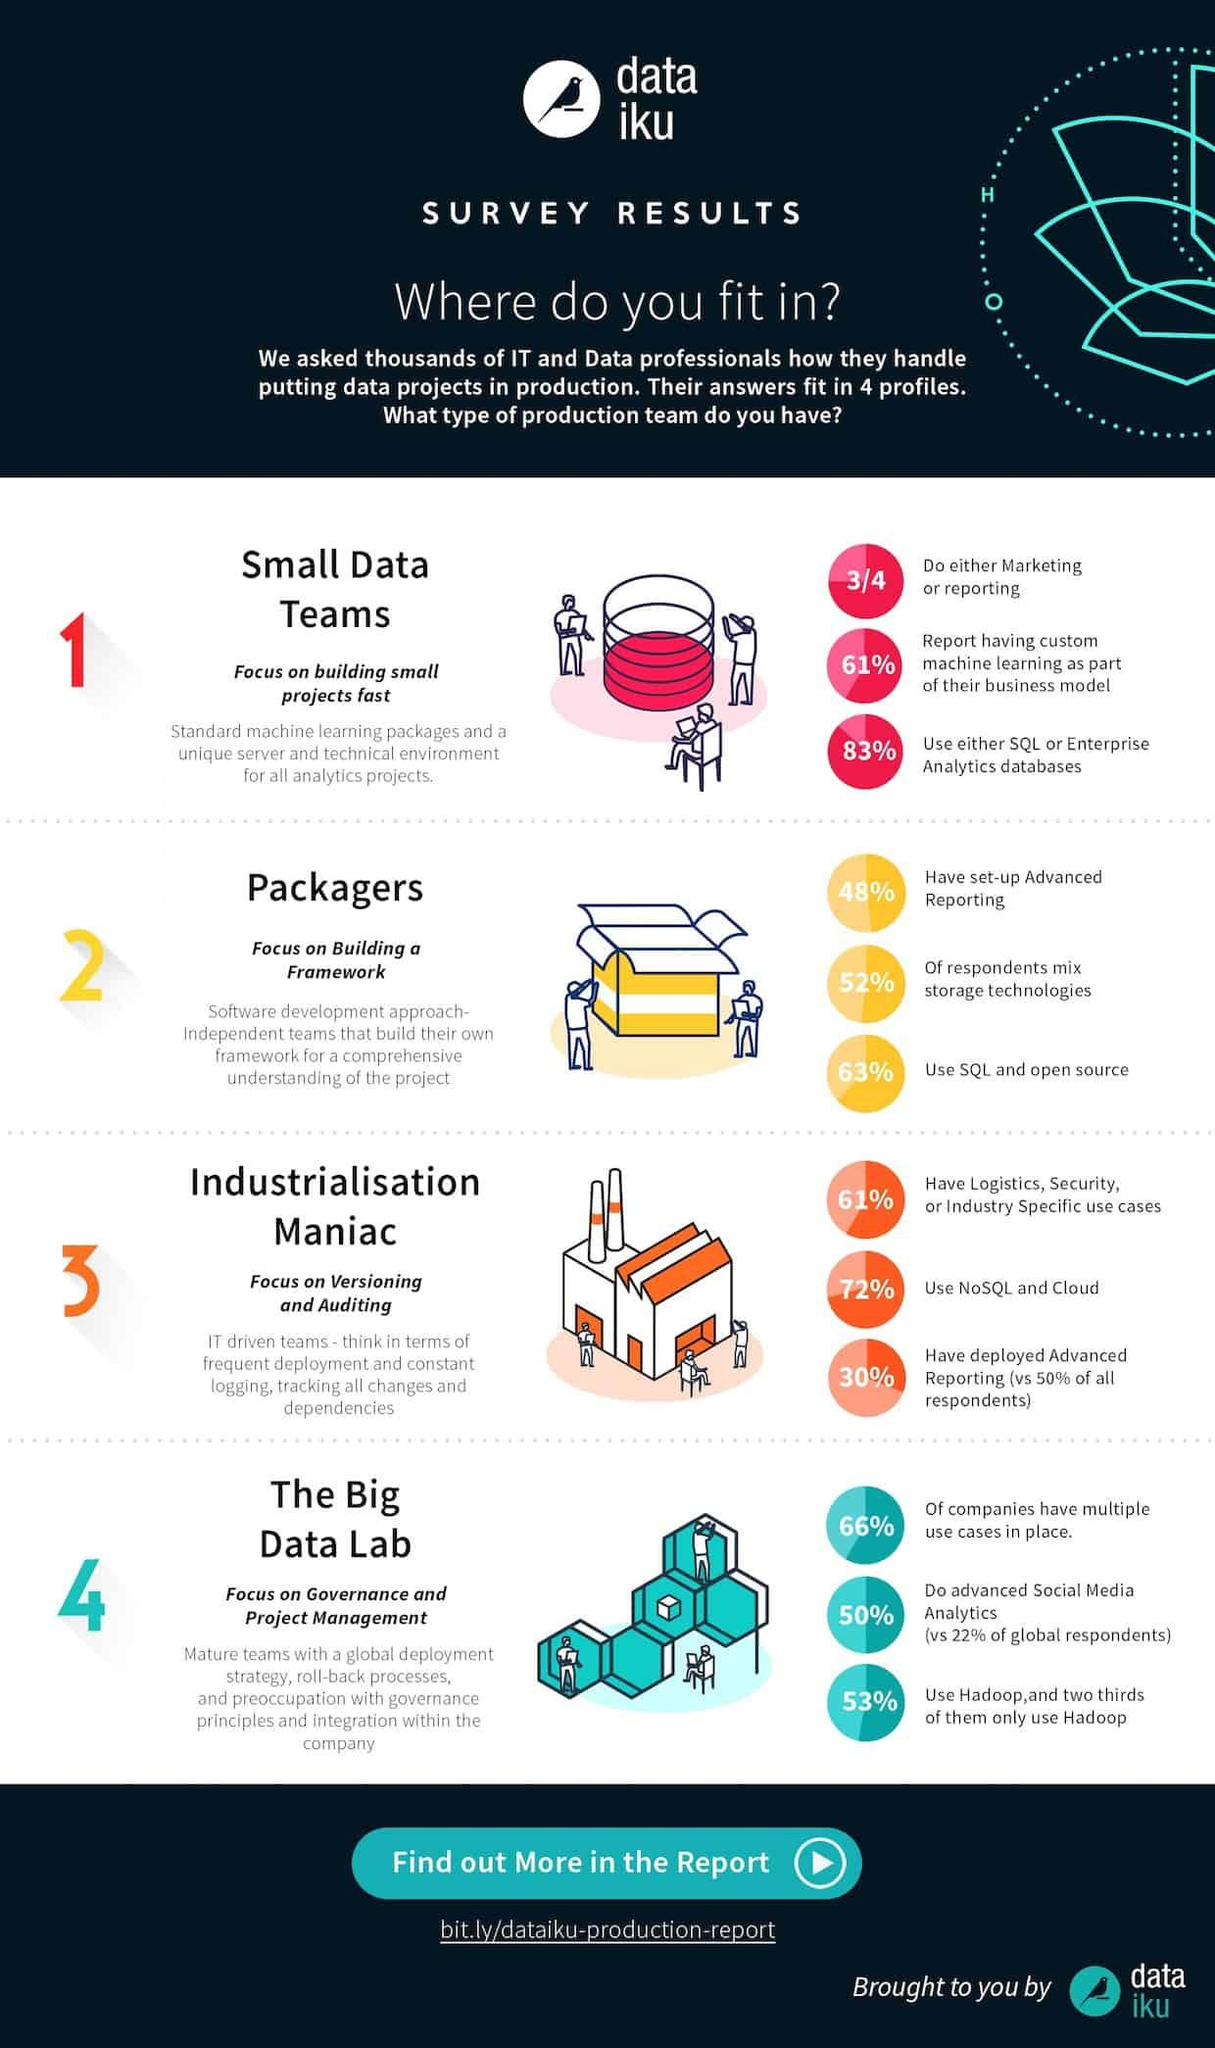Specify some key components in this picture. According to a survey, 70% of people have not deployed advanced reporting. According to the given data, 28% of people are not using NoSQL and Cloud. According to the provided information, approximately 17% of people do not use either SQL or Enterprise Analytics databases. Out of every four people, one does not engage in either marketing or reporting. According to a recent survey, a majority of people, or 47%, are not currently using Hadoop. 